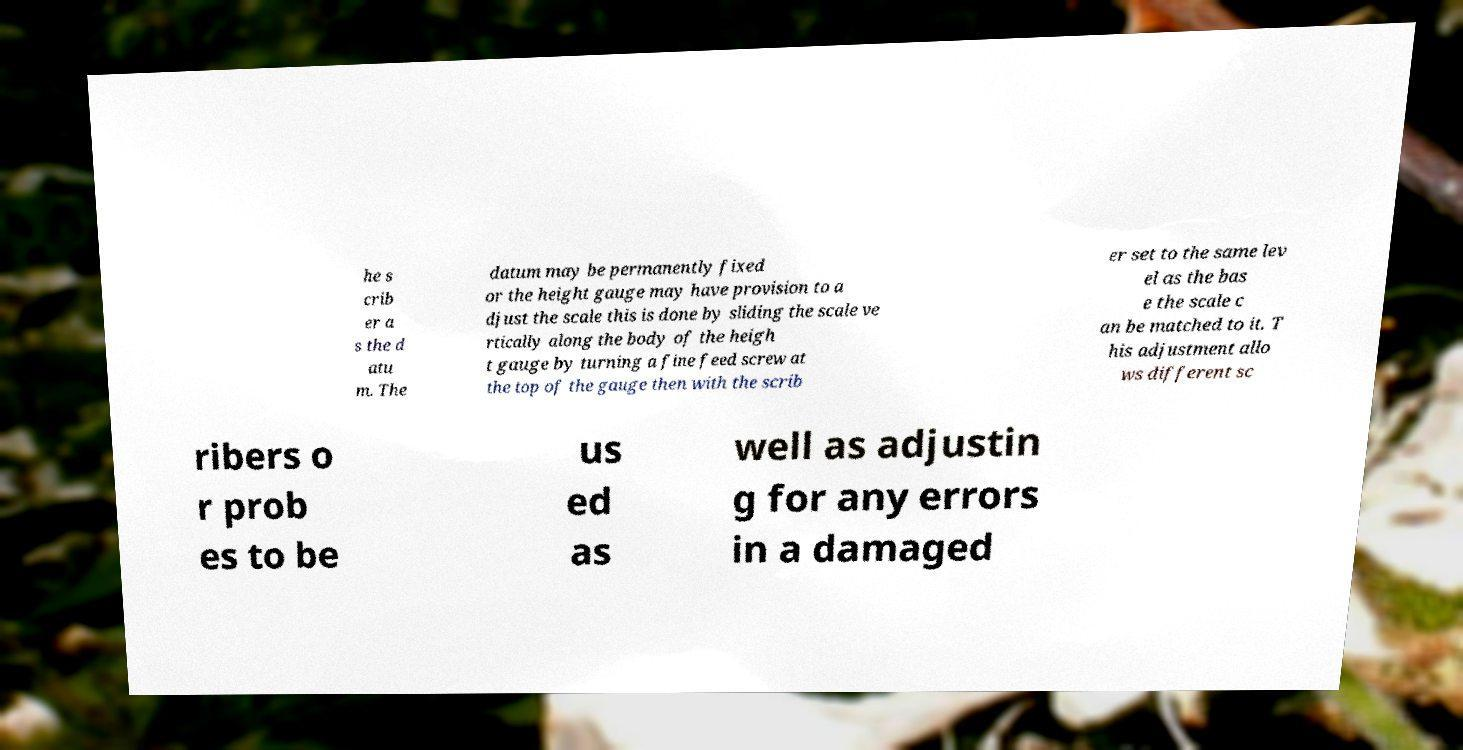Can you read and provide the text displayed in the image?This photo seems to have some interesting text. Can you extract and type it out for me? he s crib er a s the d atu m. The datum may be permanently fixed or the height gauge may have provision to a djust the scale this is done by sliding the scale ve rtically along the body of the heigh t gauge by turning a fine feed screw at the top of the gauge then with the scrib er set to the same lev el as the bas e the scale c an be matched to it. T his adjustment allo ws different sc ribers o r prob es to be us ed as well as adjustin g for any errors in a damaged 